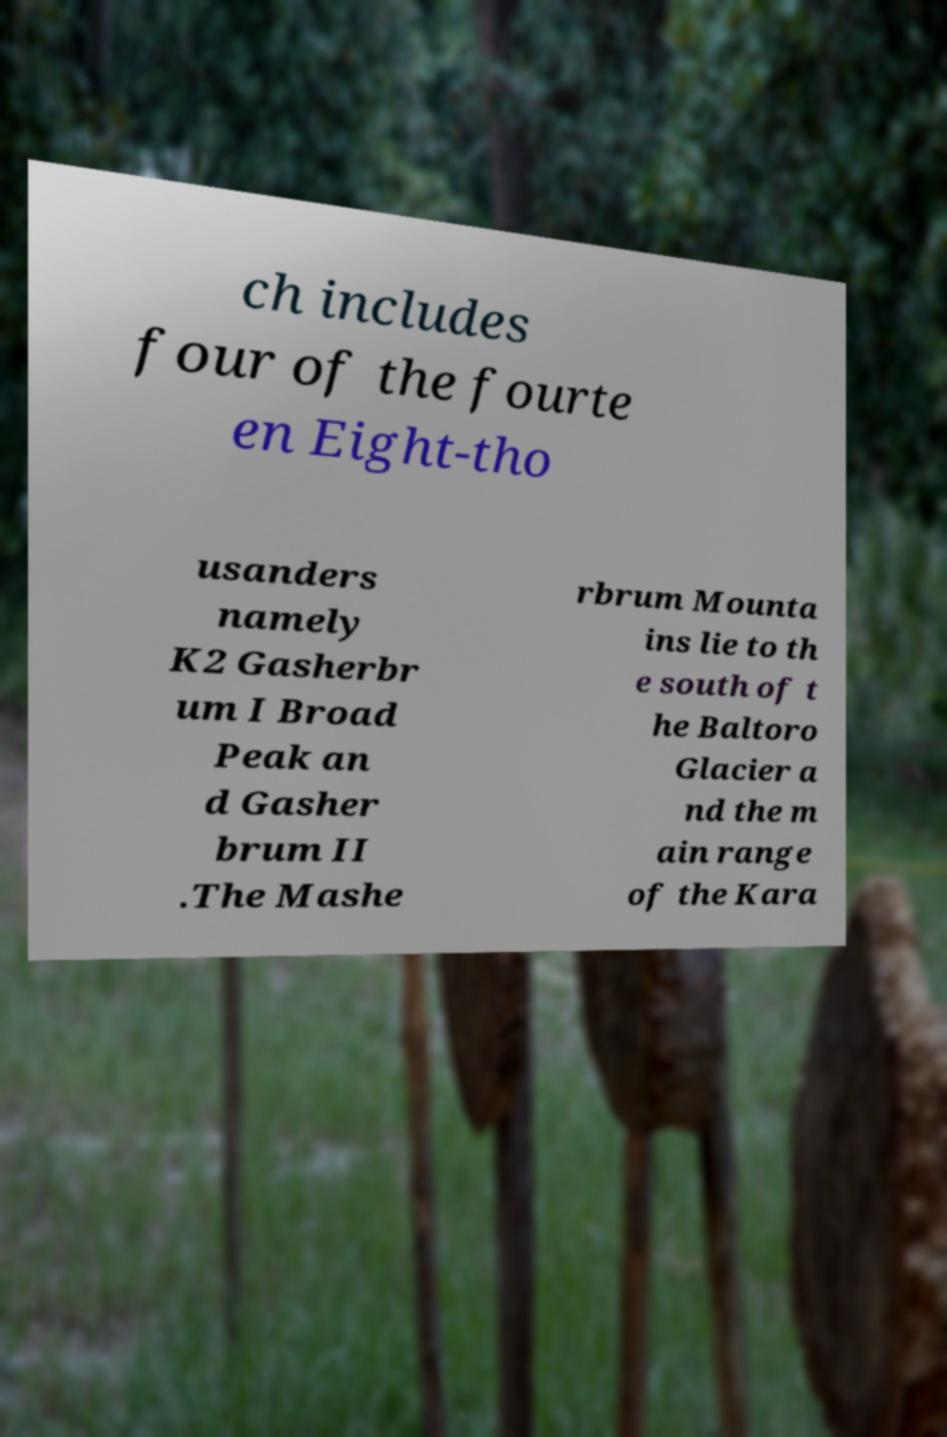Can you accurately transcribe the text from the provided image for me? ch includes four of the fourte en Eight-tho usanders namely K2 Gasherbr um I Broad Peak an d Gasher brum II .The Mashe rbrum Mounta ins lie to th e south of t he Baltoro Glacier a nd the m ain range of the Kara 